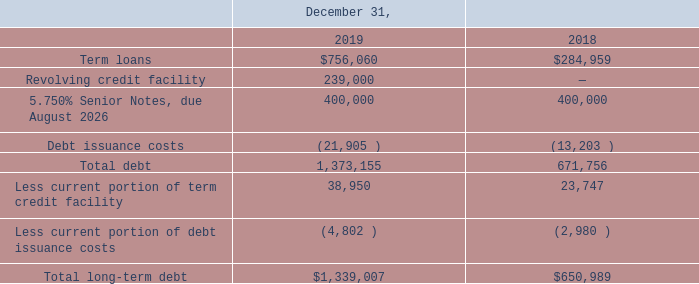The Credit Agreement and 2026 Notes contain certain customary affirmative covenants and negative covenants that limit or restrict, subject to certain exceptions, the incurrence of liens, indebtedness of subsidiaries, mergers, advances, investments, acquisitions, transactions with affiliates, change in nature of business, and the sale of the assets. In addition, the Credit Agreement and 2026 Notes contain certain customary mandatory prepayment provisions. The Company is also required to maintain a consolidated leverage ratio at or below a specified amount and an interest coverage ratio at or above a specified amount. As specified in the Credit Agreement and 2026 Notes agreement, if certain events occur and continue, the Company may be required to repay all amounts outstanding under the Credit Facility and 2026 Notes. As of December 31, 2019, and at all times during the period, the Company was in compliance with its financial debt covenants.
Total debt is comprised of the following (in thousands):
What were the term loans in 2019?
Answer scale should be: thousand. $756,060. What were the term loans in 2018?
Answer scale should be: thousand. $284,959. What was the Revolving credit facility in 2019?
Answer scale should be: thousand. 239,000. What was the change in term loans between 2018 and 2019?
Answer scale should be: thousand. $756,060-$284,959
Answer: 471101. What was the change in total debt between 2018 and 2019?
Answer scale should be: thousand. 1,373,155-671,756
Answer: 701399. What was the percentage change in total long-term debt between 2018 and 2019?
Answer scale should be: percent. ($1,339,007-$650,989)/$650,989
Answer: 105.69. 